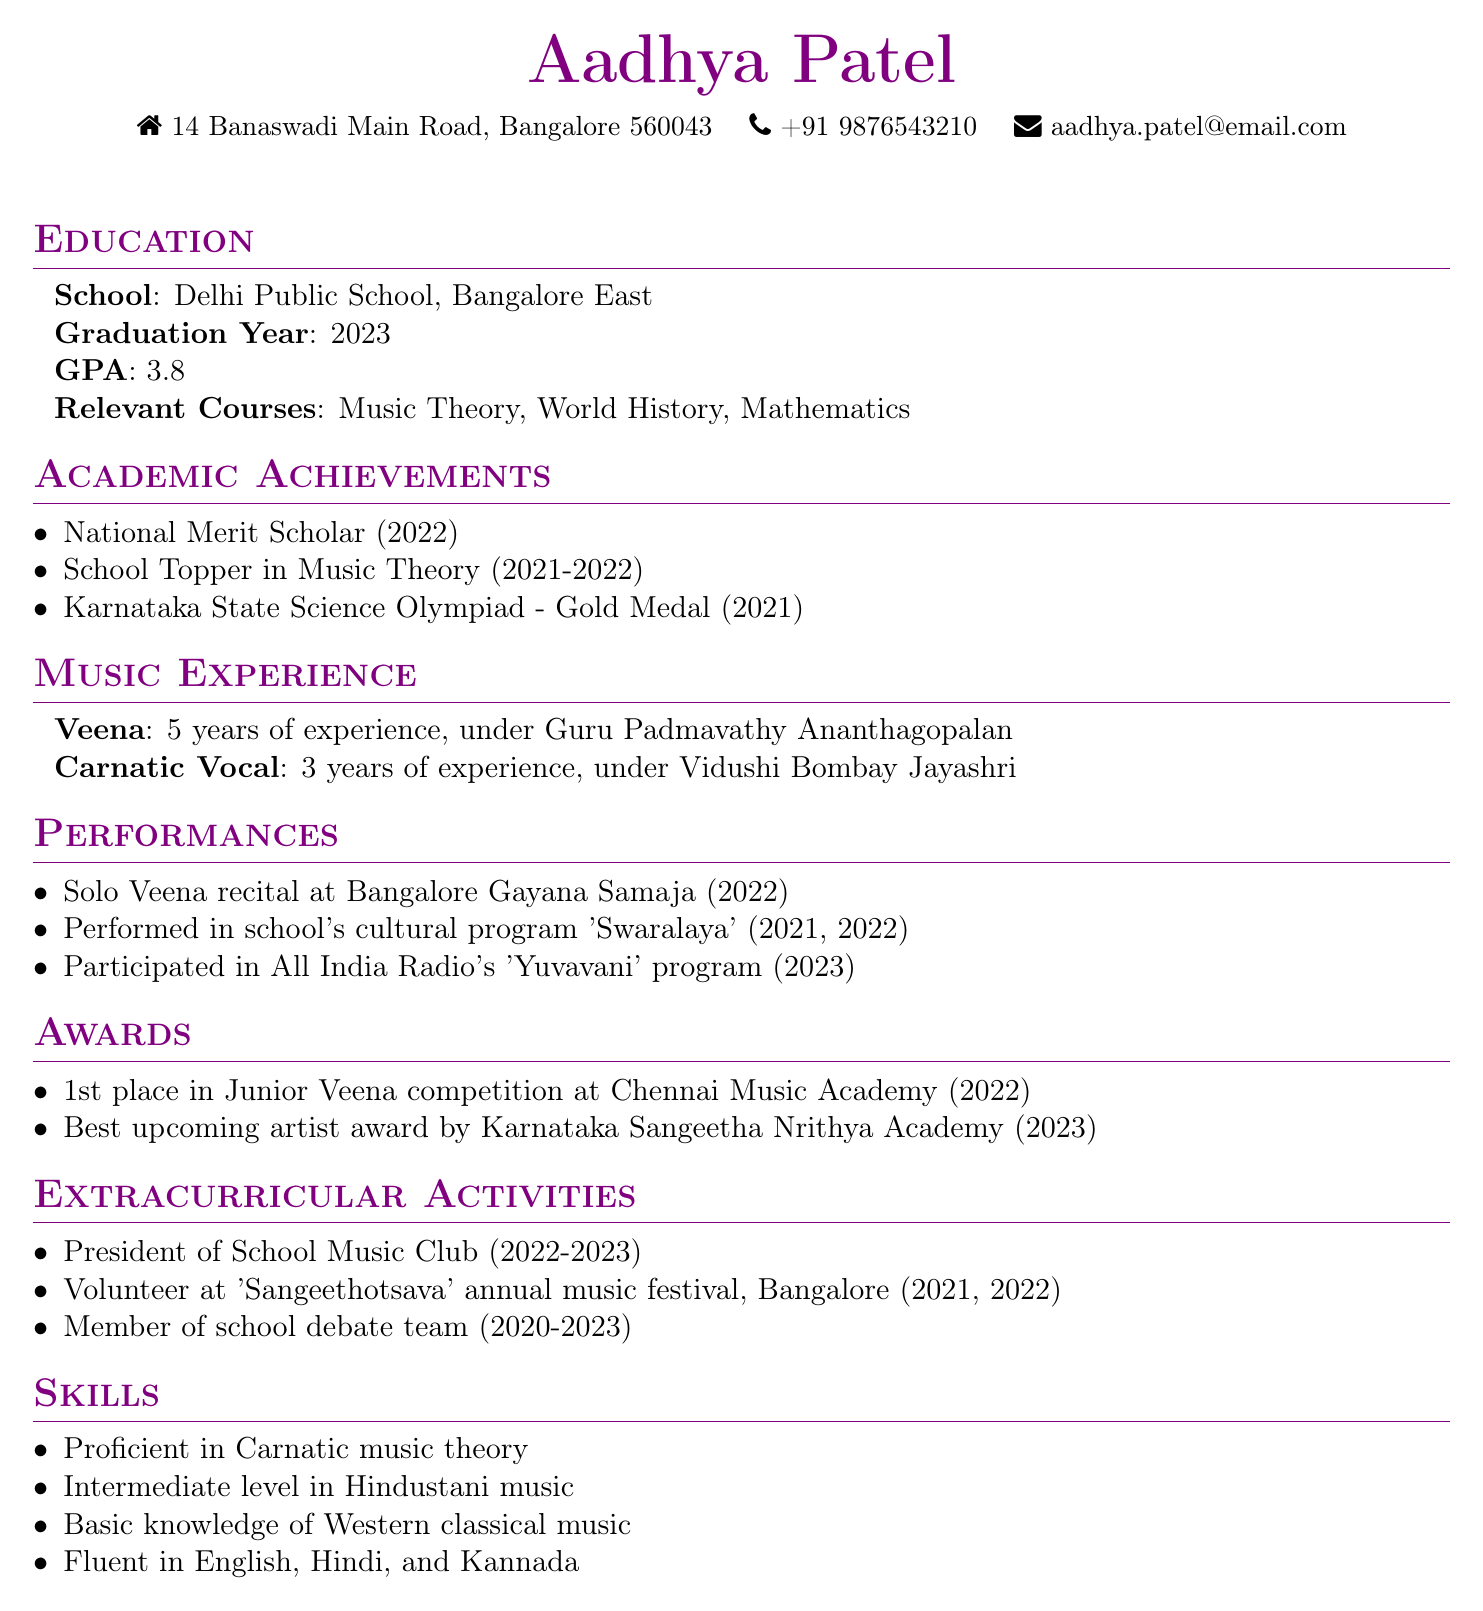what is the name of the applicant? The name of the applicant is prominently displayed at the top of the document.
Answer: Aadhya Patel which school did the applicant attend? The applicant lists their school in the education section of the document.
Answer: Delhi Public School, Bangalore East what is the graduation year of the applicant? The graduation year is mentioned in the education section as well.
Answer: 2023 how many years of experience does the applicant have in playing Veena? The years of experience in playing Veena is stated in the music experience section.
Answer: 5 years which competition did the applicant win 1st place in? The applicant's awards section mentions this specific competition.
Answer: Junior Veena competition at Chennai Music Academy who was the applicant's teacher for Veena? The document specifies the teacher in the music experience section.
Answer: Guru Padmavathy Ananthagopalan what role did the applicant hold in the School Music Club? The applicant's position is listed in the extracurricular activities section.
Answer: President how many languages is the applicant fluent in? Language proficiency is detailed in the skills section of the document.
Answer: 3 languages 